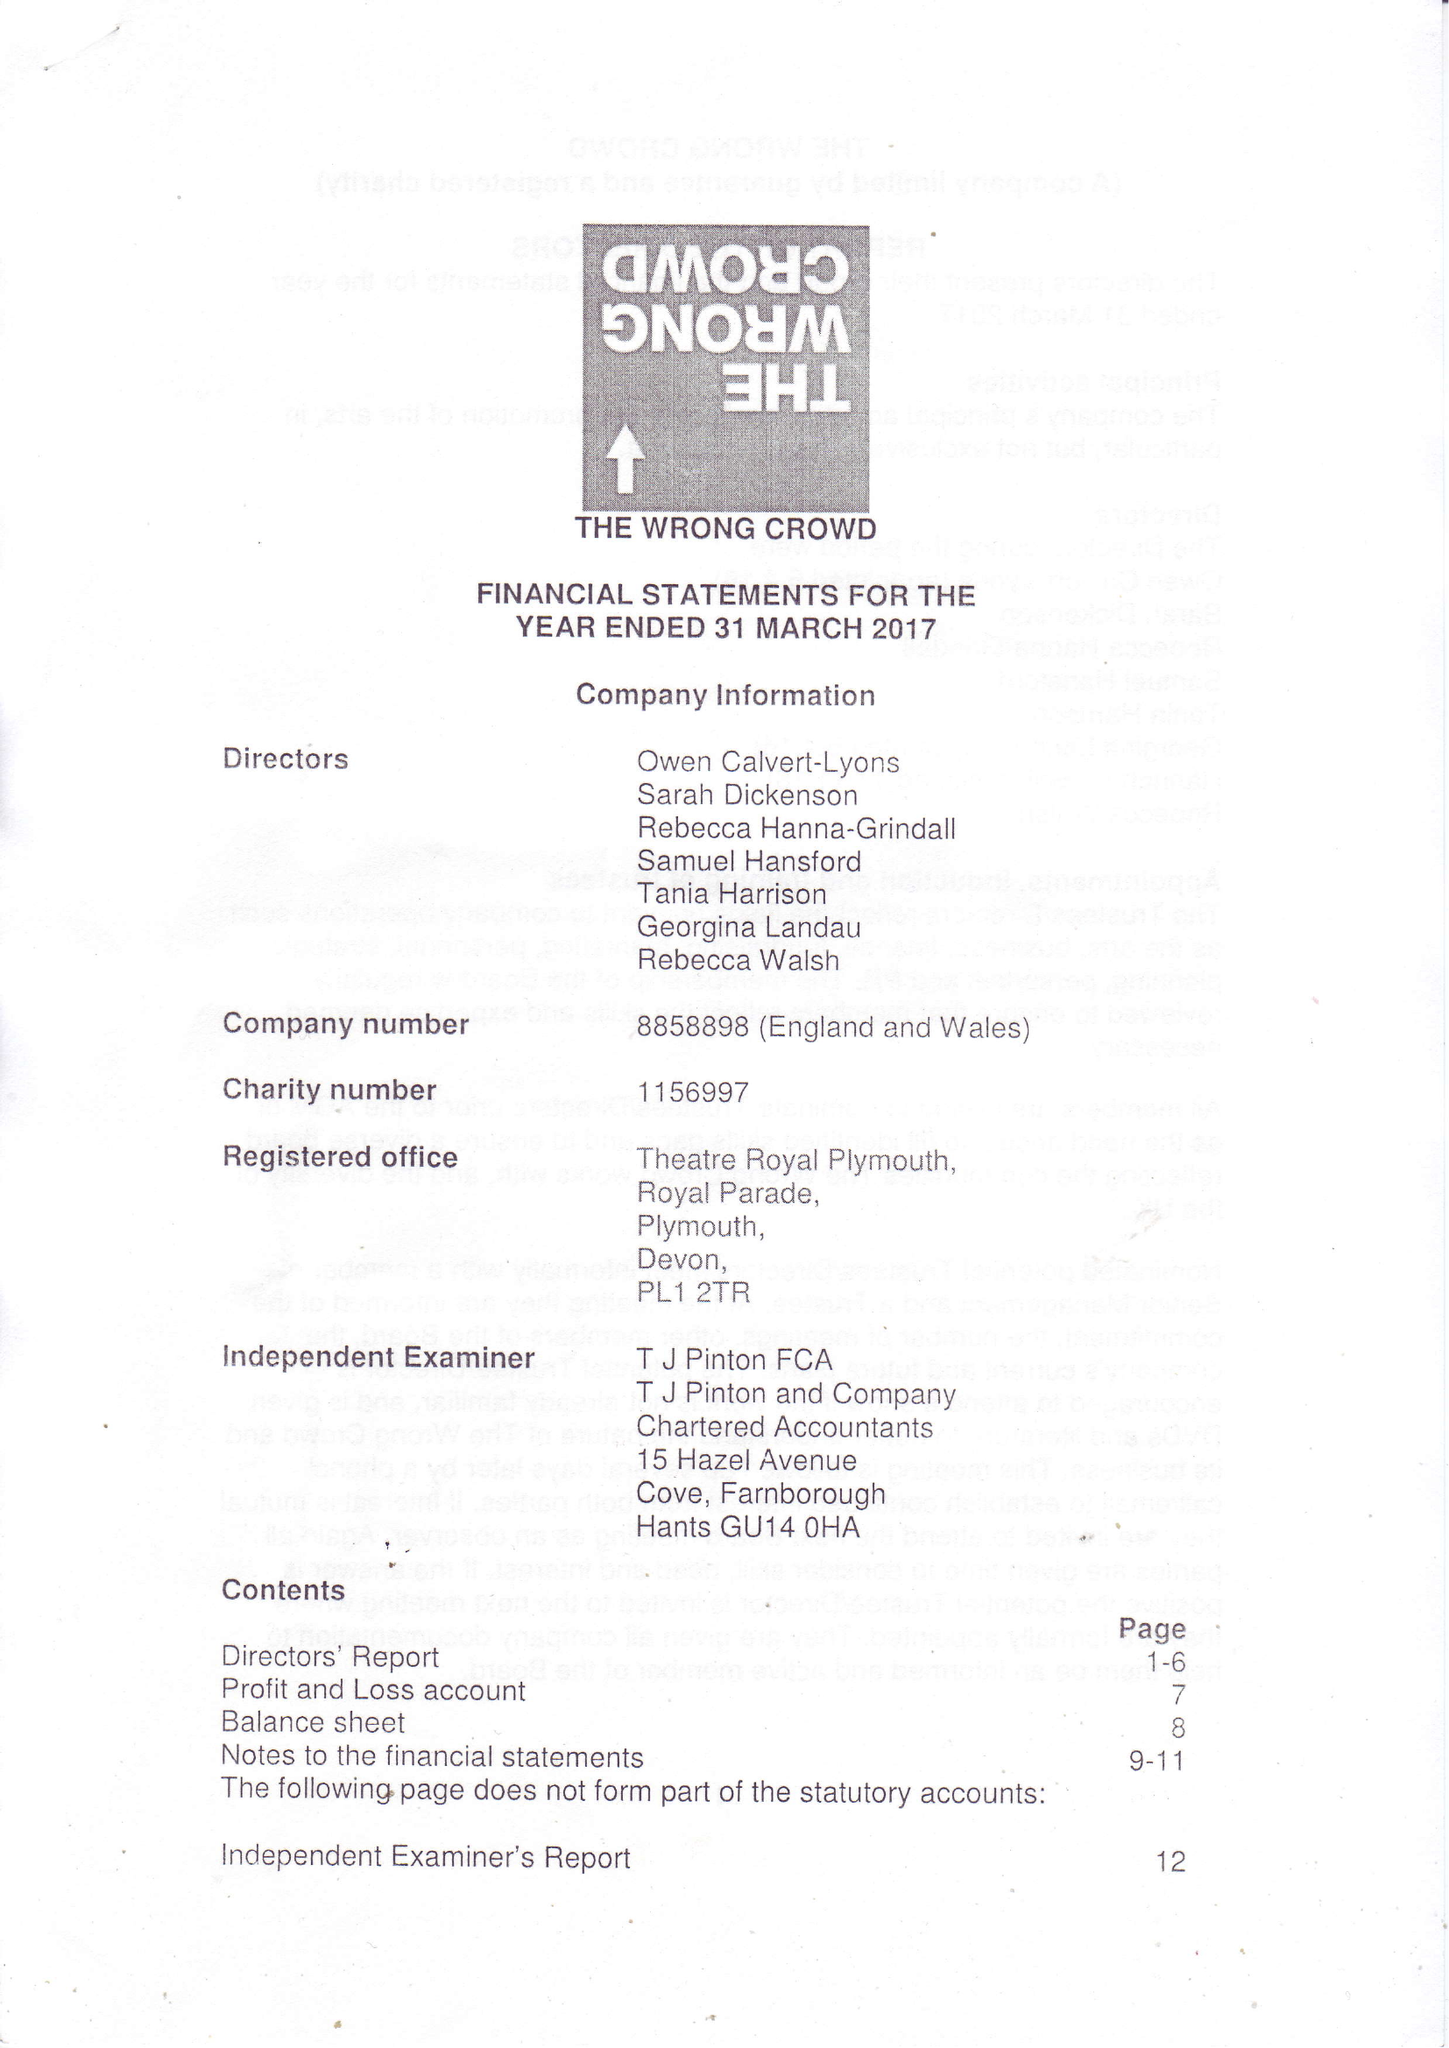What is the value for the address__street_line?
Answer the question using a single word or phrase. None 